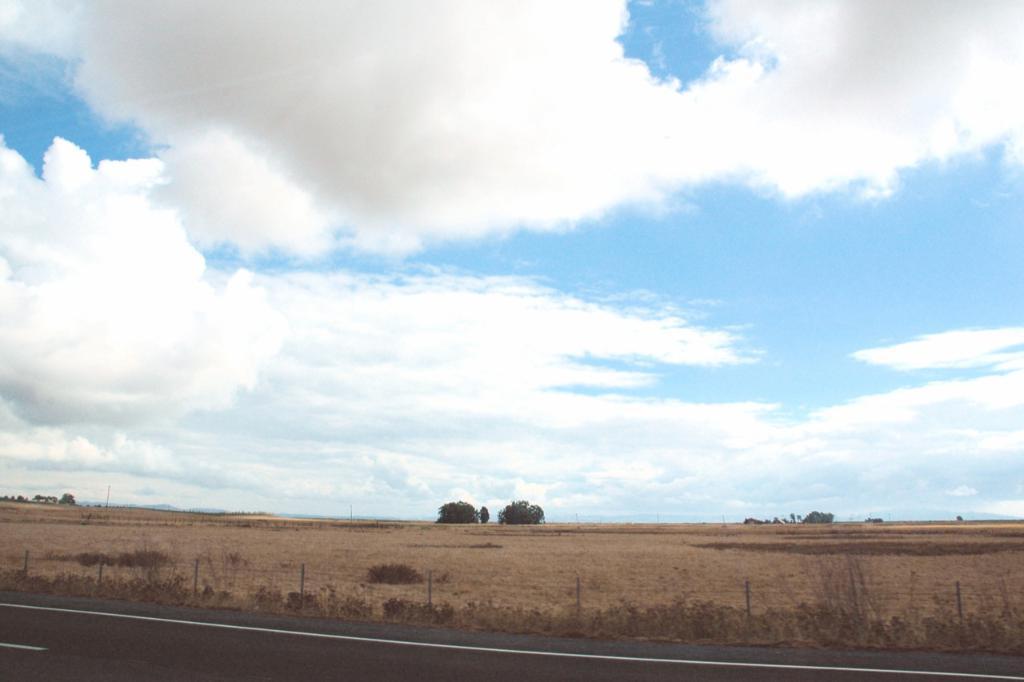In one or two sentences, can you explain what this image depicts? In the picture I can see trees, fence, white lines on the road and grass. In the background I can see the sky. 